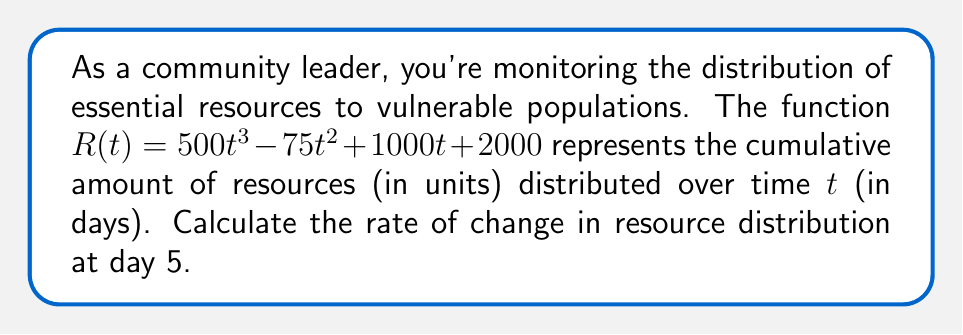Could you help me with this problem? To find the rate of change in resource distribution at a specific point in time, we need to calculate the derivative of the given function and evaluate it at the given point.

Step 1: Find the derivative of $R(t)$.
$$R'(t) = \frac{d}{dt}(500t^3 - 75t^2 + 1000t + 2000)$$
$$R'(t) = 1500t^2 - 150t + 1000$$

Step 2: Evaluate the derivative at $t = 5$.
$$R'(5) = 1500(5)^2 - 150(5) + 1000$$
$$R'(5) = 1500(25) - 750 + 1000$$
$$R'(5) = 37500 - 750 + 1000$$
$$R'(5) = 37750$$

The rate of change at day 5 is 37,750 units per day.
Answer: 37,750 units/day 